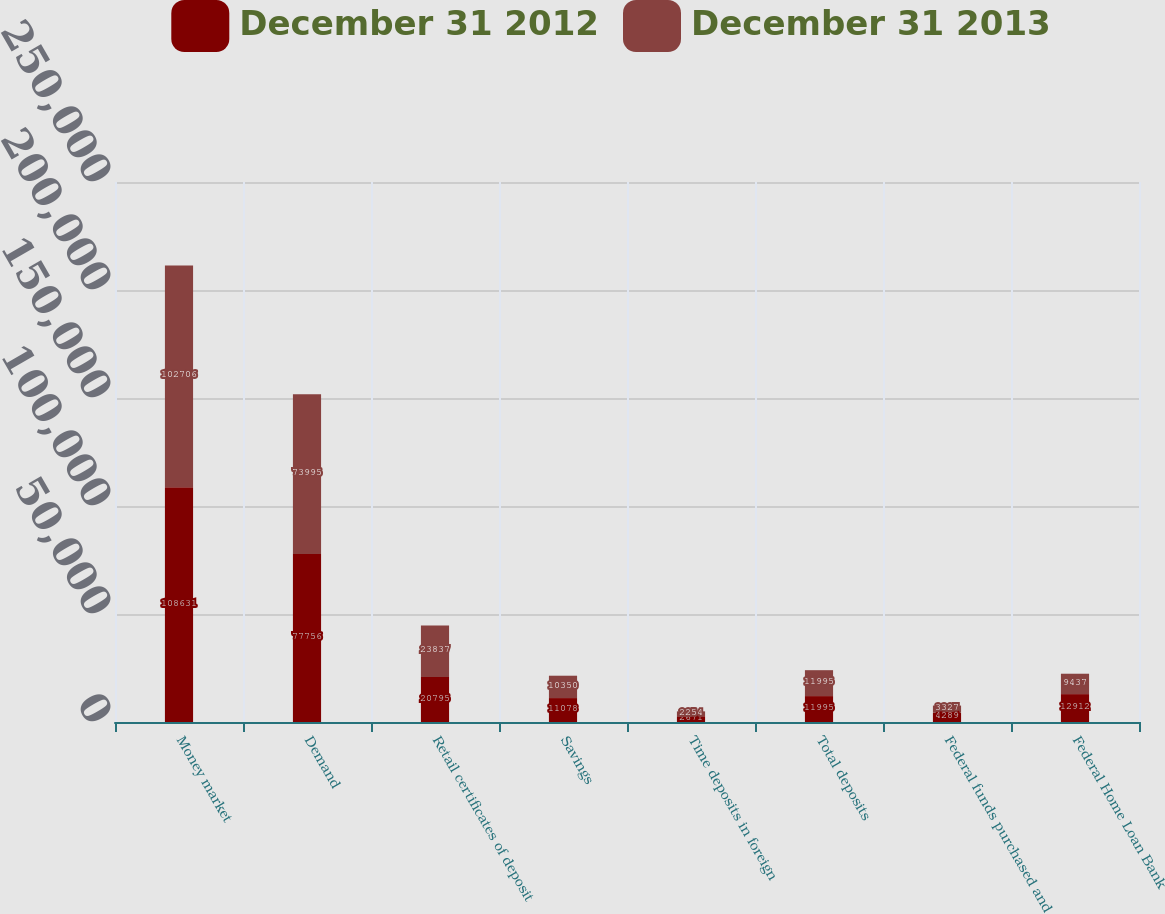Convert chart. <chart><loc_0><loc_0><loc_500><loc_500><stacked_bar_chart><ecel><fcel>Money market<fcel>Demand<fcel>Retail certificates of deposit<fcel>Savings<fcel>Time deposits in foreign<fcel>Total deposits<fcel>Federal funds purchased and<fcel>Federal Home Loan Bank<nl><fcel>December 31 2012<fcel>108631<fcel>77756<fcel>20795<fcel>11078<fcel>2671<fcel>11995<fcel>4289<fcel>12912<nl><fcel>December 31 2013<fcel>102706<fcel>73995<fcel>23837<fcel>10350<fcel>2254<fcel>11995<fcel>3327<fcel>9437<nl></chart> 